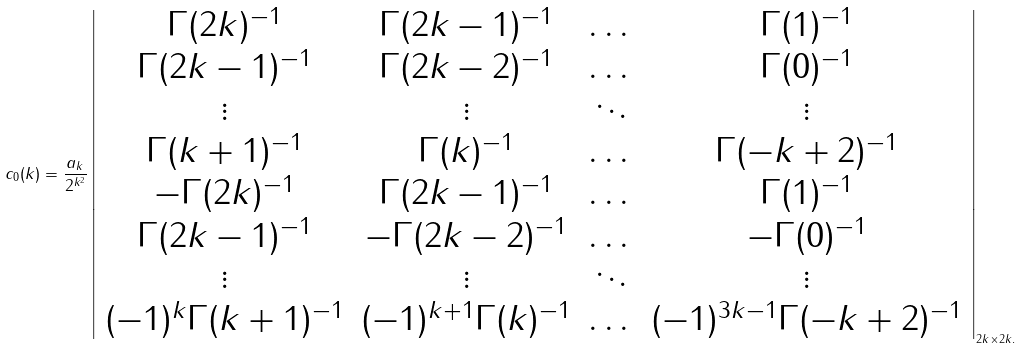Convert formula to latex. <formula><loc_0><loc_0><loc_500><loc_500>c _ { 0 } ( k ) = \frac { a _ { k } } { 2 ^ { k ^ { 2 } } } \left | \begin{array} { c c c c } \Gamma ( 2 k ) ^ { - 1 } & \Gamma ( 2 k - 1 ) ^ { - 1 } & \dots & \Gamma ( 1 ) ^ { - 1 } \\ \Gamma ( 2 k - 1 ) ^ { - 1 } & \Gamma ( 2 k - 2 ) ^ { - 1 } & \dots & \Gamma ( 0 ) ^ { - 1 } \\ \vdots & \vdots & \ddots & \vdots \\ \Gamma ( k + 1 ) ^ { - 1 } & \Gamma ( k ) ^ { - 1 } & \dots & \Gamma ( - k + 2 ) ^ { - 1 } \\ - \Gamma ( 2 k ) ^ { - 1 } & \Gamma ( 2 k - 1 ) ^ { - 1 } & \dots & \Gamma ( 1 ) ^ { - 1 } \\ \Gamma ( 2 k - 1 ) ^ { - 1 } & - \Gamma ( 2 k - 2 ) ^ { - 1 } & \dots & - \Gamma ( 0 ) ^ { - 1 } \\ \vdots & \vdots & \ddots & \vdots \\ ( - 1 ) ^ { k } \Gamma ( k + 1 ) ^ { - 1 } & ( - 1 ) ^ { k + 1 } \Gamma ( k ) ^ { - 1 } & \dots & ( - 1 ) ^ { 3 k - 1 } \Gamma ( - k + 2 ) ^ { - 1 } \end{array} \right | _ { 2 k \times 2 k . } \quad</formula> 